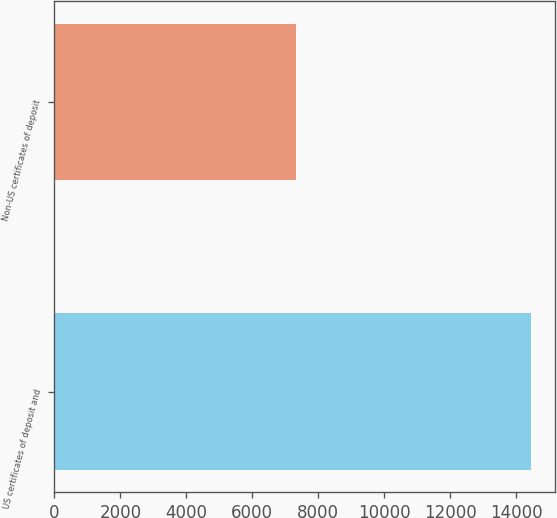Convert chart. <chart><loc_0><loc_0><loc_500><loc_500><bar_chart><fcel>US certificates of deposit and<fcel>Non-US certificates of deposit<nl><fcel>14441<fcel>7317<nl></chart> 